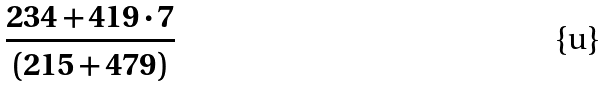<formula> <loc_0><loc_0><loc_500><loc_500>\frac { 2 3 4 + 4 1 9 \cdot 7 } { ( 2 1 5 + 4 7 9 ) }</formula> 